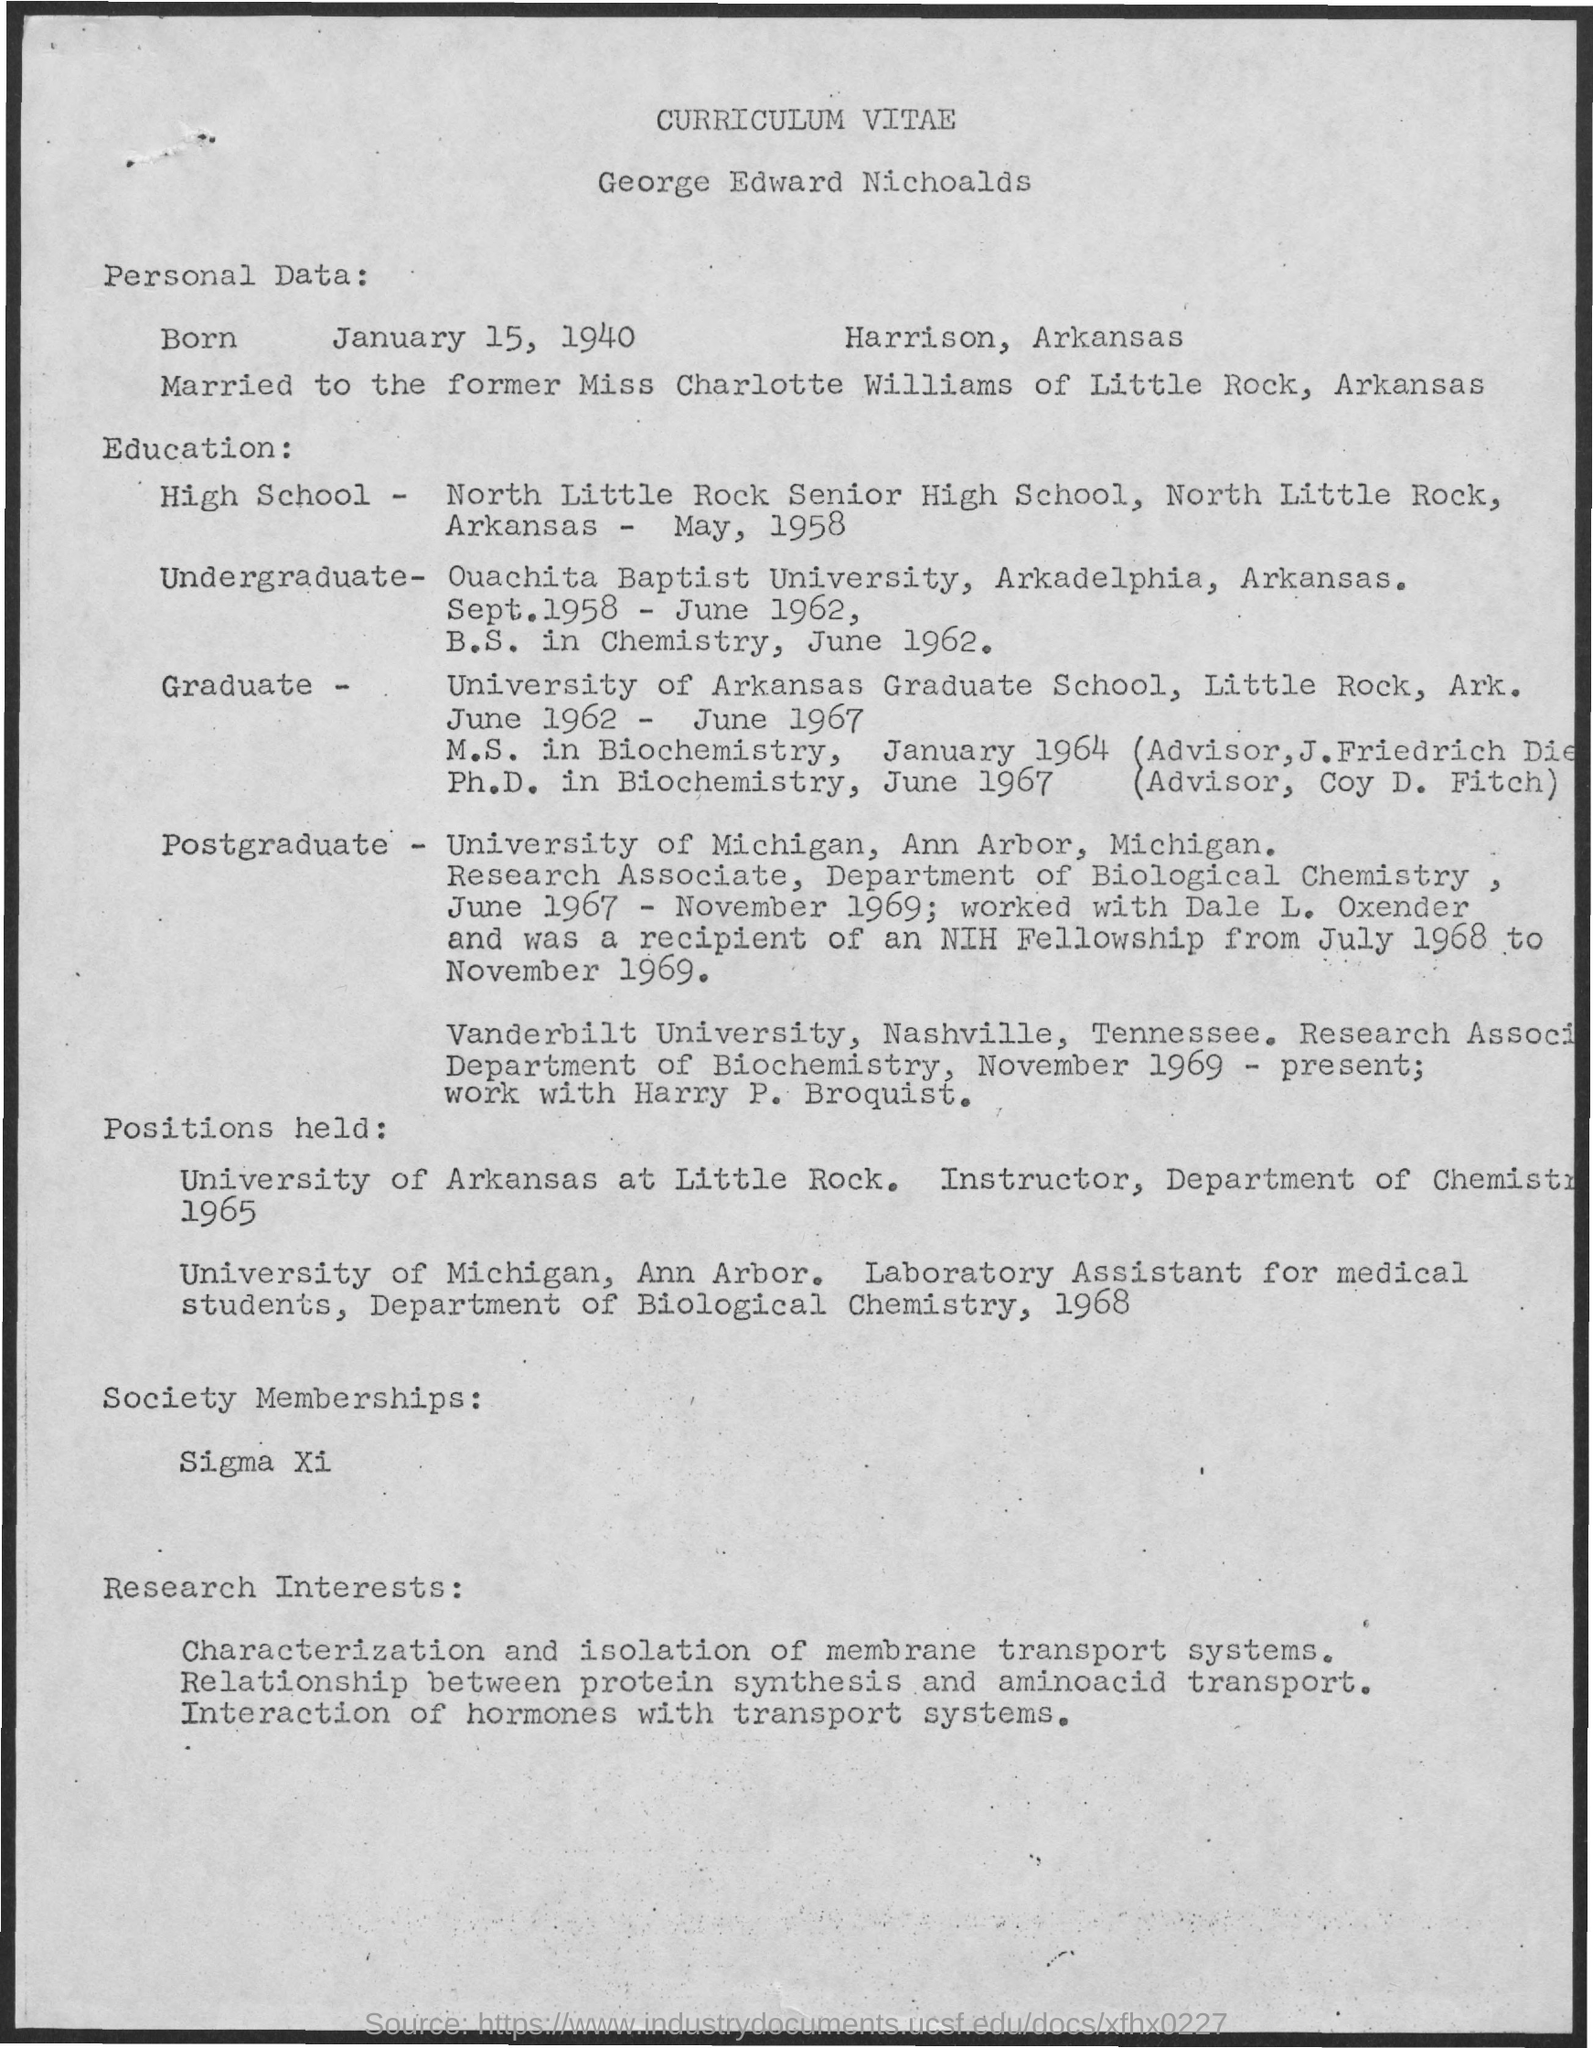Outline some significant characteristics in this image. The date of birth of George is January 15, 1940. George studied at North Little Rock Senior High School. 